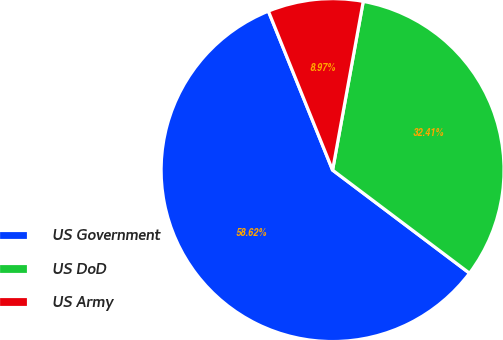Convert chart. <chart><loc_0><loc_0><loc_500><loc_500><pie_chart><fcel>US Government<fcel>US DoD<fcel>US Army<nl><fcel>58.62%<fcel>32.41%<fcel>8.97%<nl></chart> 